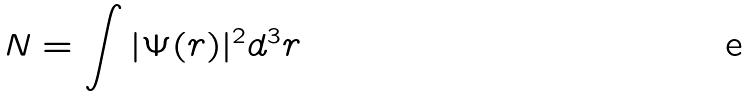Convert formula to latex. <formula><loc_0><loc_0><loc_500><loc_500>N = \int | \Psi ( r ) | ^ { 2 } d ^ { 3 } r</formula> 